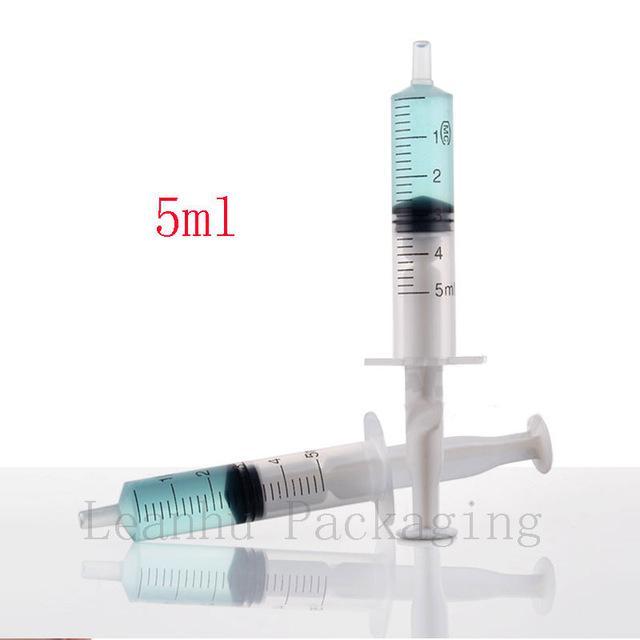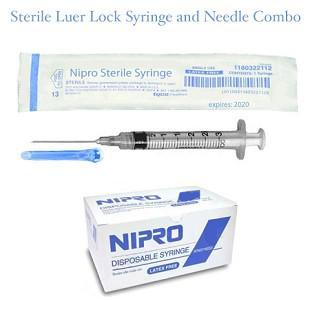The first image is the image on the left, the second image is the image on the right. For the images displayed, is the sentence "In the image to the right, the needle is NOT connected to the syringe; the syringe cannot presently enter the skin." factually correct? Answer yes or no. No. The first image is the image on the left, the second image is the image on the right. Given the left and right images, does the statement "There are exactly two syringes." hold true? Answer yes or no. No. 